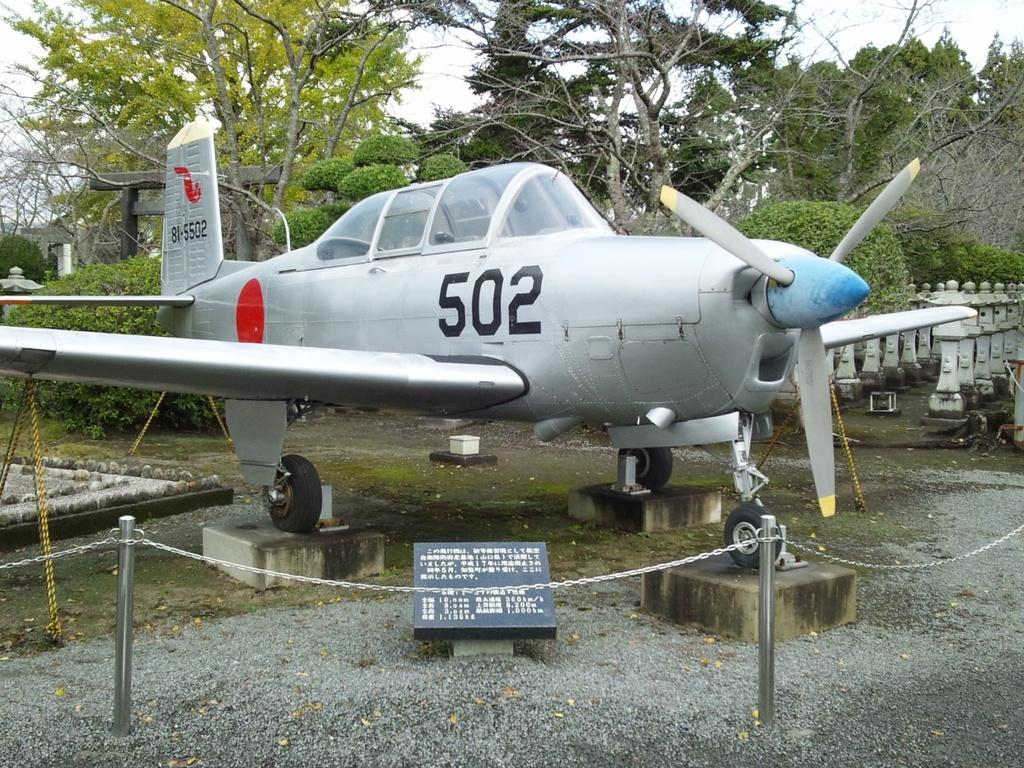What is the main subject of the image? The main subject of the image is a helicopter. What color is the helicopter? The helicopter is grey in color. What is surrounding the helicopter in the image? There are poles with chains around the helicopter. What can be seen in the background of the image? There are trees and the sky visible in the background of the image. What type of feast is being prepared in the helicopter? There is no indication of a feast or any food preparation in the image; it features a helicopter surrounded by poles with chains. Is there a doctor present in the image? There is no doctor or any medical personnel visible in the image. 